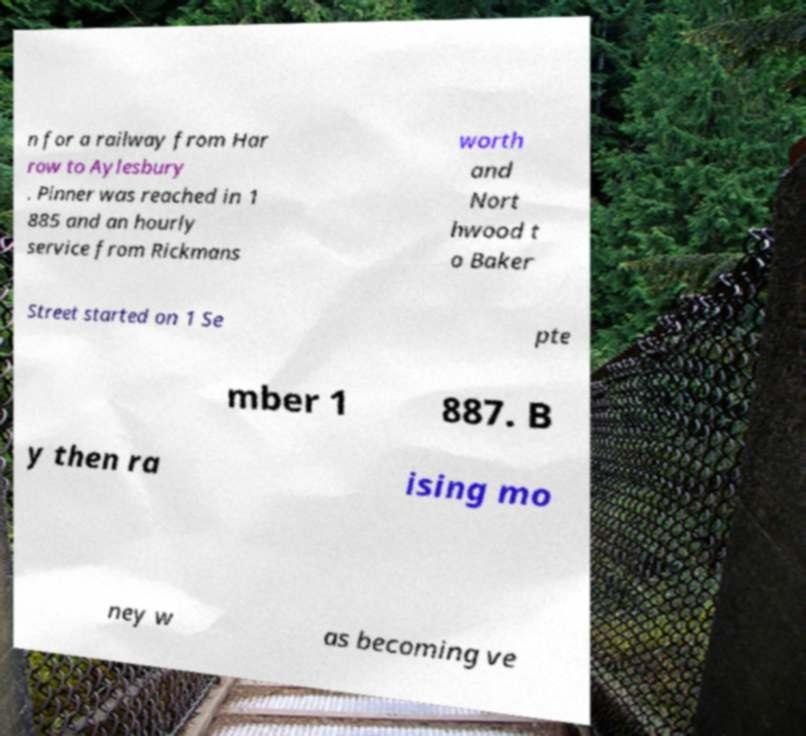I need the written content from this picture converted into text. Can you do that? n for a railway from Har row to Aylesbury . Pinner was reached in 1 885 and an hourly service from Rickmans worth and Nort hwood t o Baker Street started on 1 Se pte mber 1 887. B y then ra ising mo ney w as becoming ve 